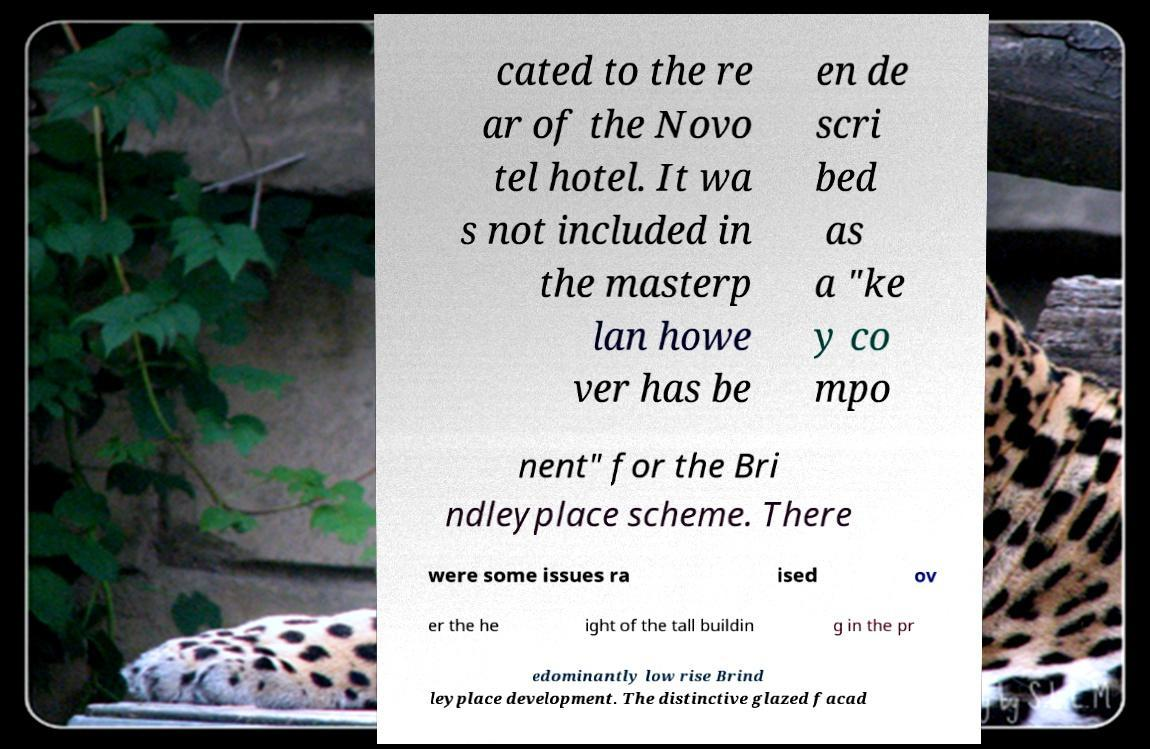What messages or text are displayed in this image? I need them in a readable, typed format. cated to the re ar of the Novo tel hotel. It wa s not included in the masterp lan howe ver has be en de scri bed as a "ke y co mpo nent" for the Bri ndleyplace scheme. There were some issues ra ised ov er the he ight of the tall buildin g in the pr edominantly low rise Brind leyplace development. The distinctive glazed facad 